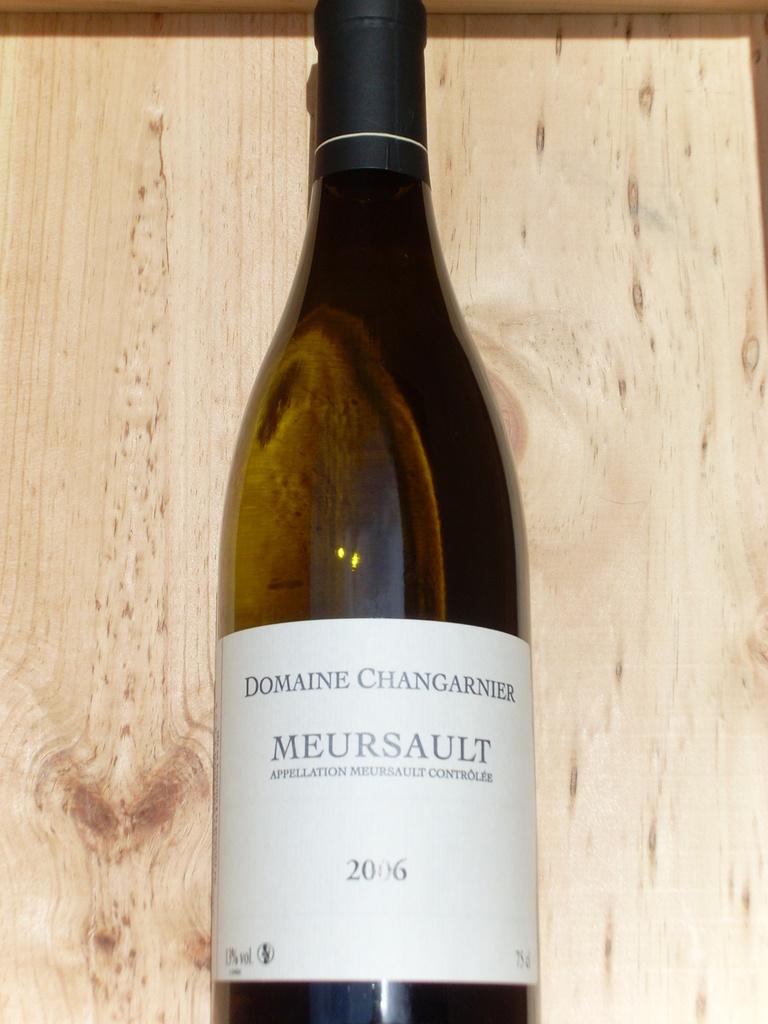Is this a chef's manual?
Offer a very short reply. No. 